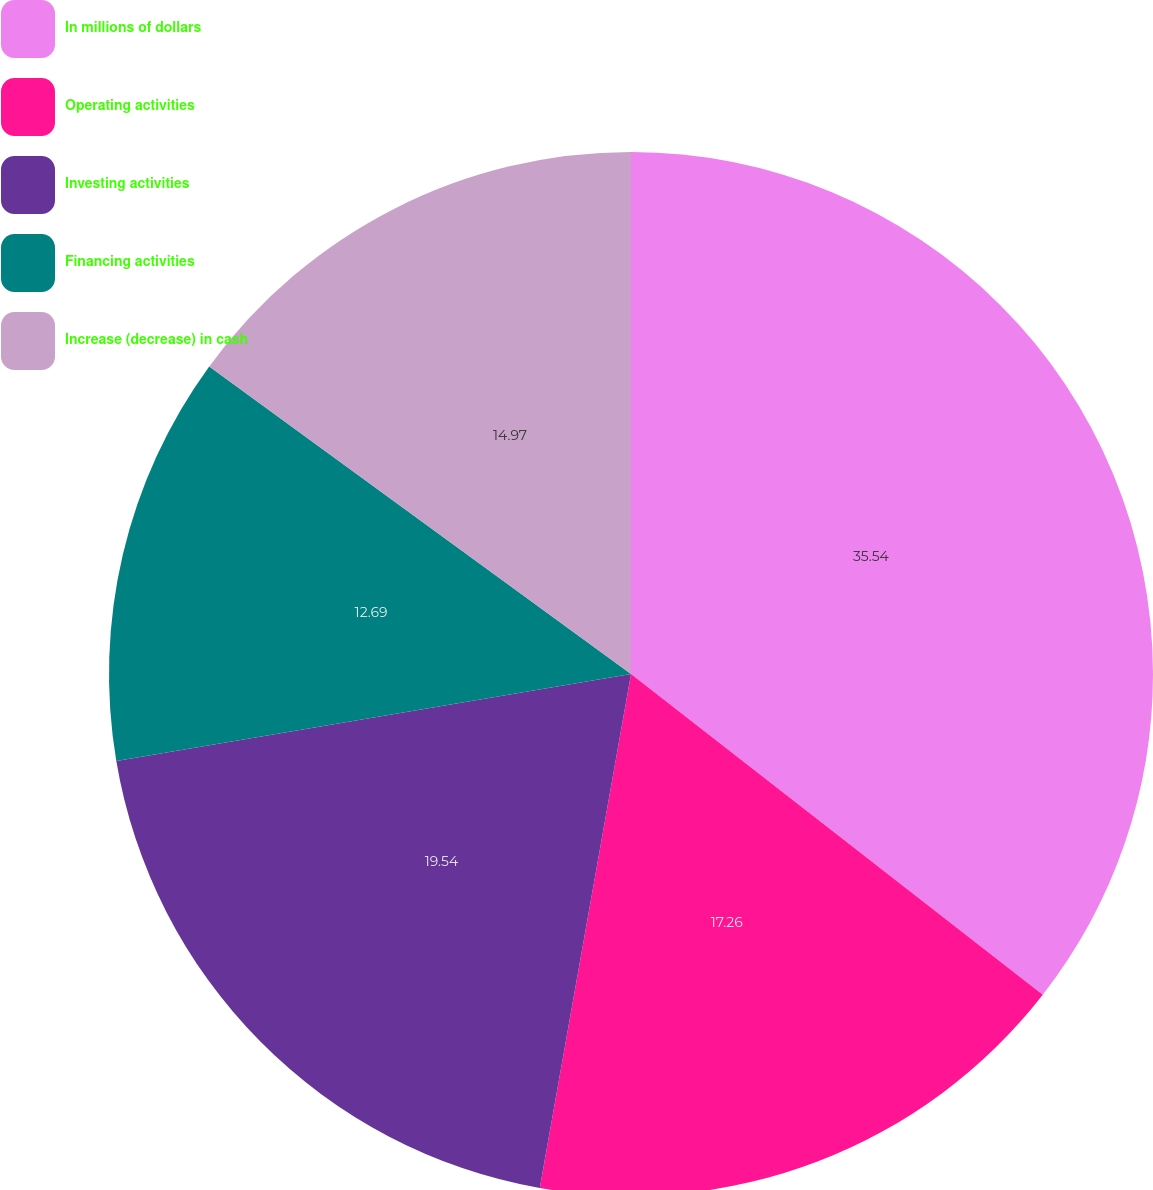Convert chart to OTSL. <chart><loc_0><loc_0><loc_500><loc_500><pie_chart><fcel>In millions of dollars<fcel>Operating activities<fcel>Investing activities<fcel>Financing activities<fcel>Increase (decrease) in cash<nl><fcel>35.53%<fcel>17.26%<fcel>19.54%<fcel>12.69%<fcel>14.97%<nl></chart> 